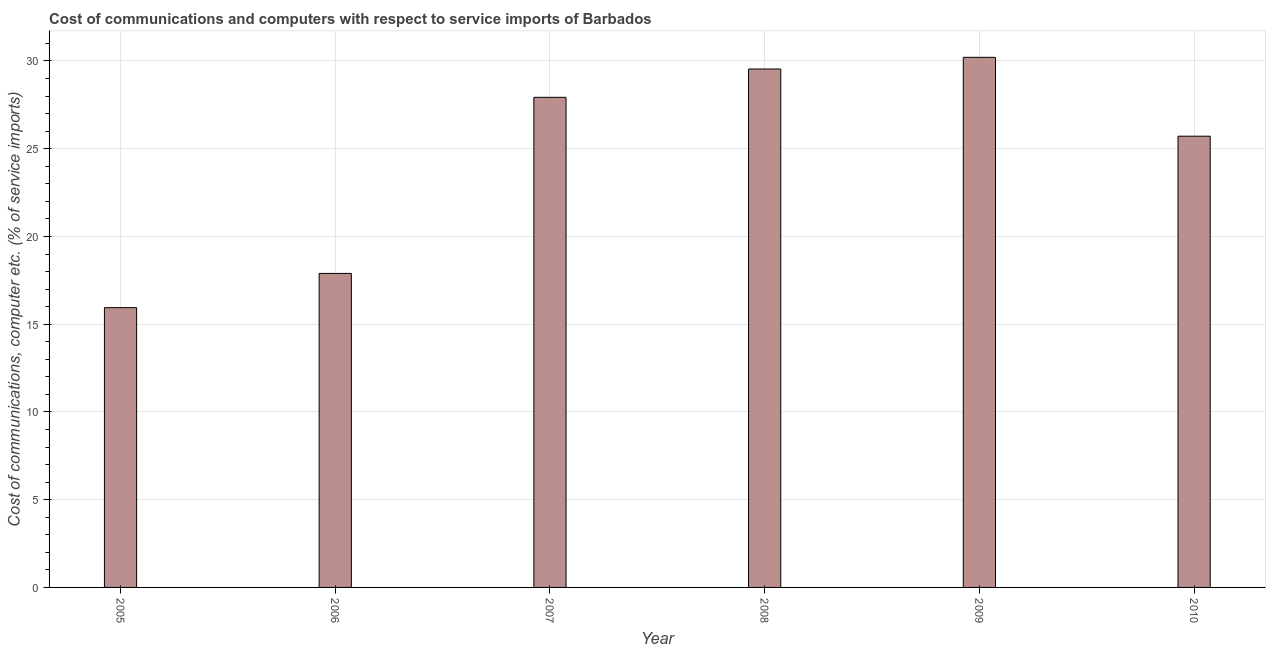Does the graph contain any zero values?
Offer a terse response. No. Does the graph contain grids?
Your response must be concise. Yes. What is the title of the graph?
Your answer should be compact. Cost of communications and computers with respect to service imports of Barbados. What is the label or title of the Y-axis?
Your answer should be compact. Cost of communications, computer etc. (% of service imports). What is the cost of communications and computer in 2006?
Your answer should be compact. 17.89. Across all years, what is the maximum cost of communications and computer?
Make the answer very short. 30.21. Across all years, what is the minimum cost of communications and computer?
Provide a short and direct response. 15.94. In which year was the cost of communications and computer maximum?
Provide a succinct answer. 2009. What is the sum of the cost of communications and computer?
Make the answer very short. 147.23. What is the difference between the cost of communications and computer in 2005 and 2008?
Provide a succinct answer. -13.6. What is the average cost of communications and computer per year?
Offer a very short reply. 24.54. What is the median cost of communications and computer?
Make the answer very short. 26.82. In how many years, is the cost of communications and computer greater than 19 %?
Provide a succinct answer. 4. What is the ratio of the cost of communications and computer in 2005 to that in 2009?
Keep it short and to the point. 0.53. Is the cost of communications and computer in 2006 less than that in 2007?
Provide a succinct answer. Yes. What is the difference between the highest and the second highest cost of communications and computer?
Keep it short and to the point. 0.67. Is the sum of the cost of communications and computer in 2006 and 2010 greater than the maximum cost of communications and computer across all years?
Keep it short and to the point. Yes. What is the difference between the highest and the lowest cost of communications and computer?
Give a very brief answer. 14.26. How many bars are there?
Offer a terse response. 6. Are all the bars in the graph horizontal?
Ensure brevity in your answer.  No. How many years are there in the graph?
Your answer should be very brief. 6. What is the difference between two consecutive major ticks on the Y-axis?
Provide a short and direct response. 5. What is the Cost of communications, computer etc. (% of service imports) of 2005?
Give a very brief answer. 15.94. What is the Cost of communications, computer etc. (% of service imports) in 2006?
Provide a short and direct response. 17.89. What is the Cost of communications, computer etc. (% of service imports) of 2007?
Your response must be concise. 27.93. What is the Cost of communications, computer etc. (% of service imports) in 2008?
Make the answer very short. 29.54. What is the Cost of communications, computer etc. (% of service imports) of 2009?
Offer a terse response. 30.21. What is the Cost of communications, computer etc. (% of service imports) in 2010?
Your response must be concise. 25.71. What is the difference between the Cost of communications, computer etc. (% of service imports) in 2005 and 2006?
Provide a short and direct response. -1.95. What is the difference between the Cost of communications, computer etc. (% of service imports) in 2005 and 2007?
Offer a very short reply. -11.99. What is the difference between the Cost of communications, computer etc. (% of service imports) in 2005 and 2008?
Your response must be concise. -13.6. What is the difference between the Cost of communications, computer etc. (% of service imports) in 2005 and 2009?
Give a very brief answer. -14.26. What is the difference between the Cost of communications, computer etc. (% of service imports) in 2005 and 2010?
Offer a terse response. -9.77. What is the difference between the Cost of communications, computer etc. (% of service imports) in 2006 and 2007?
Give a very brief answer. -10.03. What is the difference between the Cost of communications, computer etc. (% of service imports) in 2006 and 2008?
Your response must be concise. -11.65. What is the difference between the Cost of communications, computer etc. (% of service imports) in 2006 and 2009?
Your answer should be very brief. -12.31. What is the difference between the Cost of communications, computer etc. (% of service imports) in 2006 and 2010?
Your response must be concise. -7.82. What is the difference between the Cost of communications, computer etc. (% of service imports) in 2007 and 2008?
Your response must be concise. -1.61. What is the difference between the Cost of communications, computer etc. (% of service imports) in 2007 and 2009?
Give a very brief answer. -2.28. What is the difference between the Cost of communications, computer etc. (% of service imports) in 2007 and 2010?
Provide a short and direct response. 2.21. What is the difference between the Cost of communications, computer etc. (% of service imports) in 2008 and 2009?
Your answer should be compact. -0.67. What is the difference between the Cost of communications, computer etc. (% of service imports) in 2008 and 2010?
Provide a short and direct response. 3.83. What is the difference between the Cost of communications, computer etc. (% of service imports) in 2009 and 2010?
Provide a succinct answer. 4.49. What is the ratio of the Cost of communications, computer etc. (% of service imports) in 2005 to that in 2006?
Give a very brief answer. 0.89. What is the ratio of the Cost of communications, computer etc. (% of service imports) in 2005 to that in 2007?
Provide a succinct answer. 0.57. What is the ratio of the Cost of communications, computer etc. (% of service imports) in 2005 to that in 2008?
Keep it short and to the point. 0.54. What is the ratio of the Cost of communications, computer etc. (% of service imports) in 2005 to that in 2009?
Give a very brief answer. 0.53. What is the ratio of the Cost of communications, computer etc. (% of service imports) in 2005 to that in 2010?
Provide a short and direct response. 0.62. What is the ratio of the Cost of communications, computer etc. (% of service imports) in 2006 to that in 2007?
Keep it short and to the point. 0.64. What is the ratio of the Cost of communications, computer etc. (% of service imports) in 2006 to that in 2008?
Your answer should be compact. 0.61. What is the ratio of the Cost of communications, computer etc. (% of service imports) in 2006 to that in 2009?
Give a very brief answer. 0.59. What is the ratio of the Cost of communications, computer etc. (% of service imports) in 2006 to that in 2010?
Provide a succinct answer. 0.7. What is the ratio of the Cost of communications, computer etc. (% of service imports) in 2007 to that in 2008?
Make the answer very short. 0.94. What is the ratio of the Cost of communications, computer etc. (% of service imports) in 2007 to that in 2009?
Offer a terse response. 0.93. What is the ratio of the Cost of communications, computer etc. (% of service imports) in 2007 to that in 2010?
Give a very brief answer. 1.09. What is the ratio of the Cost of communications, computer etc. (% of service imports) in 2008 to that in 2010?
Ensure brevity in your answer.  1.15. What is the ratio of the Cost of communications, computer etc. (% of service imports) in 2009 to that in 2010?
Provide a short and direct response. 1.18. 